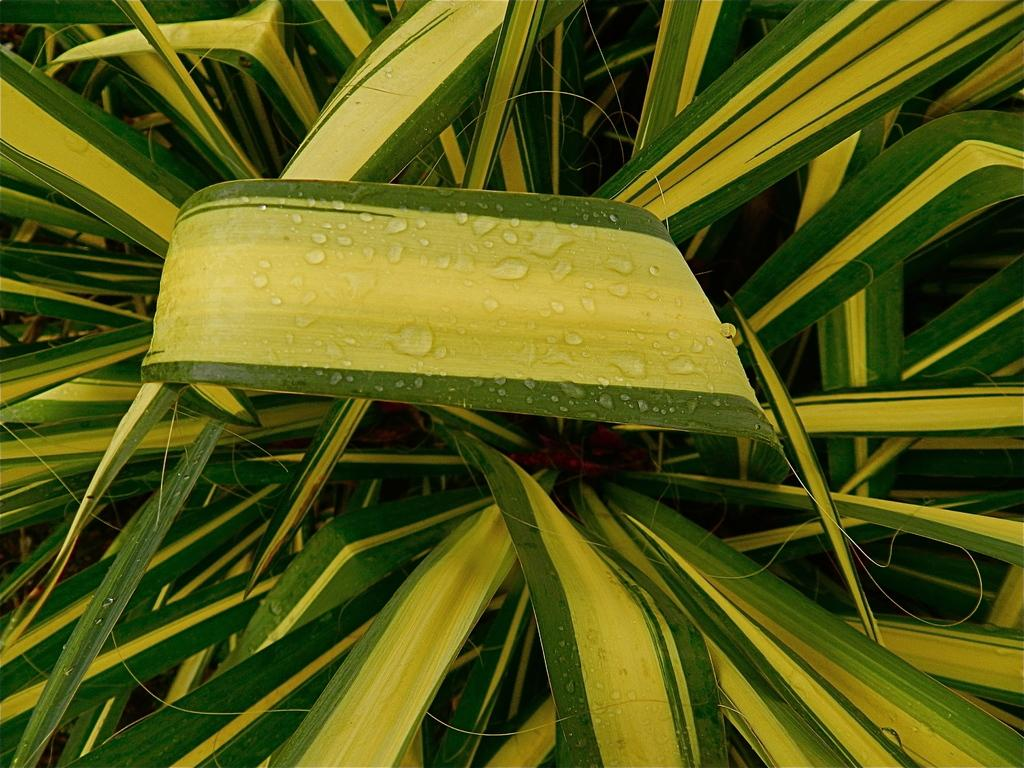What is located in the middle of the picture? There are plants in the middle of the picture. Can you describe the plants in more detail? There are water droplets on the leaf in the middle of the picture. What level of difficulty does the beginner face when trying to move the current in the image? There is no mention of a current or any difficulty related to moving it in the image. The image only features plants with water droplets on the leaf. 